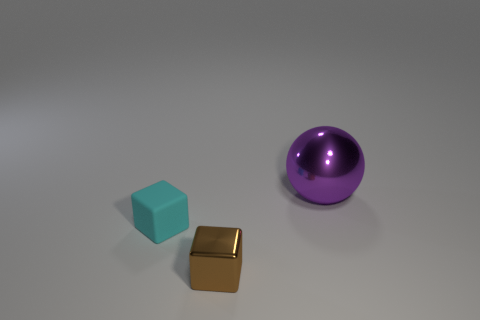What is the shape of the thing right of the metal object that is on the left side of the large purple metallic thing behind the brown thing?
Keep it short and to the point. Sphere. What color is the small block that is made of the same material as the big thing?
Give a very brief answer. Brown. There is a shiny thing that is to the right of the metal object in front of the shiny object that is behind the tiny cyan matte cube; what color is it?
Keep it short and to the point. Purple. How many cylinders are either blue shiny objects or tiny rubber objects?
Provide a succinct answer. 0. Do the large metallic sphere and the shiny object in front of the purple metallic thing have the same color?
Offer a very short reply. No. What is the color of the small rubber thing?
Provide a succinct answer. Cyan. What number of objects are large shiny cylinders or metal spheres?
Keep it short and to the point. 1. There is a brown thing that is the same size as the rubber block; what material is it?
Make the answer very short. Metal. What is the size of the metal object that is behind the matte cube?
Your response must be concise. Large. What is the cyan object made of?
Provide a succinct answer. Rubber. 